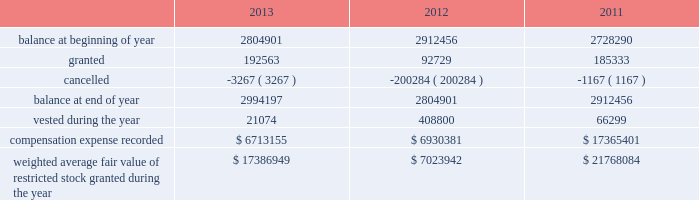During the years ended december 31 , 2013 , 2012 , and 2011 , we recognized approximately $ 6.5 million , $ 5.1 million and $ 4.7 million of compensation expense , respectively , for these options .
As of december 31 , 2013 , there was approximately $ 20.3 million of total unrecognized compensation cost related to unvested stock options , which is expected to be recognized over a weighted average period of three years .
Stock-based compensation effective january 1 , 1999 , we implemented a deferred compensation plan , or the deferred plan , covering certain of our employees , including our executives .
The shares issued under the deferred plan were granted to certain employees , including our executives and vesting will occur annually upon the completion of a service period or our meeting established financial performance criteria .
Annual vesting occurs at rates ranging from 15% ( 15 % ) to 35% ( 35 % ) once performance criteria are reached .
A summary of our restricted stock as of december 31 , 2013 , 2012 and 2011 and charges during the years then ended are presented below: .
Weighted average fair value of restricted stock granted during the year $ 17386949 $ 7023942 $ 21768084 the fair value of restricted stock that vested during the years ended december 31 , 2013 , 2012 and 2011 was $ 1.6 million , $ 22.4 million and $ 4.3 million , respectively .
As of december 31 , 2013 , there was $ 17.8 million of total unrecognized compensation cost related to unvested restricted stock , which is expected to be recognized over a weighted average period of approximately 2.7 years .
For the years ended december 31 , 2013 , 2012 and 2011 , approximately $ 4.5 million , $ 4.1 million and $ 3.4 million , respectively , was capitalized to assets associated with compensation expense related to our long-term compensation plans , restricted stock and stock options .
We granted ltip units , which include bonus , time-based and performance based awards , with a fair value of $ 27.1 million , zero and $ 8.5 million as of 2013 , 2012 and 2011 , respectively .
The grant date fair value of the ltip unit awards was calculated in accordance with asc 718 .
A third party consultant determined the fair value of the ltip units to have a discount from sl green's common stock price .
The discount was calculated by considering the inherent uncertainty that the ltip units will reach parity with other common partnership units and the illiquidity due to transfer restrictions .
As of december 31 , 2013 , there was $ 5.0 million of total unrecognized compensation expense related to the time-based and performance based awards , which is expected to be recognized over a weighted average period of approximately 1.5 years .
During the years ended december 31 , 2013 , 2012 and 2011 , we recorded compensation expense related to bonus , time-based and performance based awards of approximately $ 27.3 million , $ 12.6 million and $ 8.5 million , respectively .
2010 notional unit long-term compensation plan in december 2009 , the compensation committee of the company's board of directors approved the general terms of the sl green realty corp .
2010 notional unit long-term compensation program , or the 2010 long-term compensation plan .
The 2010 long-term compensation plan is a long-term incentive compensation plan pursuant to which award recipients could earn , in the aggregate , from approximately $ 15.0 million up to approximately $ 75.0 million of ltip units in the operating partnership based on our stock price appreciation over three years beginning on december 1 , 2009 ; provided that , if maximum performance had been achieved , approximately $ 25.0 million of awards could be earned at any time after the beginning of the second year and an additional approximately $ 25.0 million of awards could be earned at any time after the beginning of the third year .
In order to achieve maximum performance under the 2010 long-term compensation plan , our aggregate stock price appreciation during the performance period had to equal or exceed 50% ( 50 % ) .
The compensation committee determined that maximum performance had been achieved at or shortly after the beginning of each of the second and third years of the performance period and for the full performance period and , accordingly , 366815 ltip units , 385583 ltip units and 327416 ltip units were earned under the 2010 long-term compensation plan in december 2010 , 2011 and 2012 , respectively .
Substantially in accordance with the original terms of the program , 50% ( 50 % ) of these ltip units vested on december 17 , 2012 ( accelerated from the original january 1 , 2013 vesting date ) , 25% ( 25 % ) of these ltip units vested on december 11 , 2013 ( accelerated from the original january 1 , 2014 vesting date ) and the remainder is scheduled to vest on january 1 , 2015 based on .
What percentage of restricted stock was canceled in 2013? 
Computations: (3267 / 2804901)
Answer: 0.00116. 